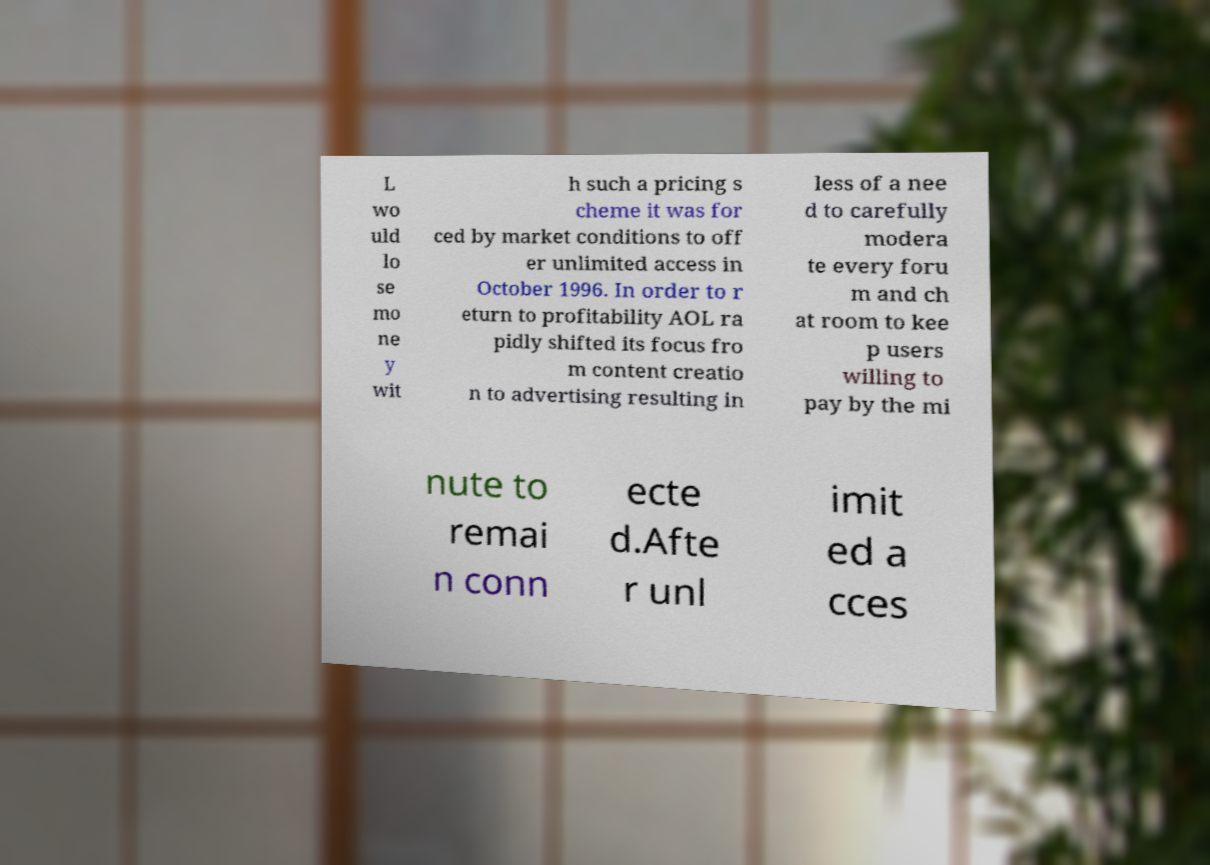Can you accurately transcribe the text from the provided image for me? L wo uld lo se mo ne y wit h such a pricing s cheme it was for ced by market conditions to off er unlimited access in October 1996. In order to r eturn to profitability AOL ra pidly shifted its focus fro m content creatio n to advertising resulting in less of a nee d to carefully modera te every foru m and ch at room to kee p users willing to pay by the mi nute to remai n conn ecte d.Afte r unl imit ed a cces 